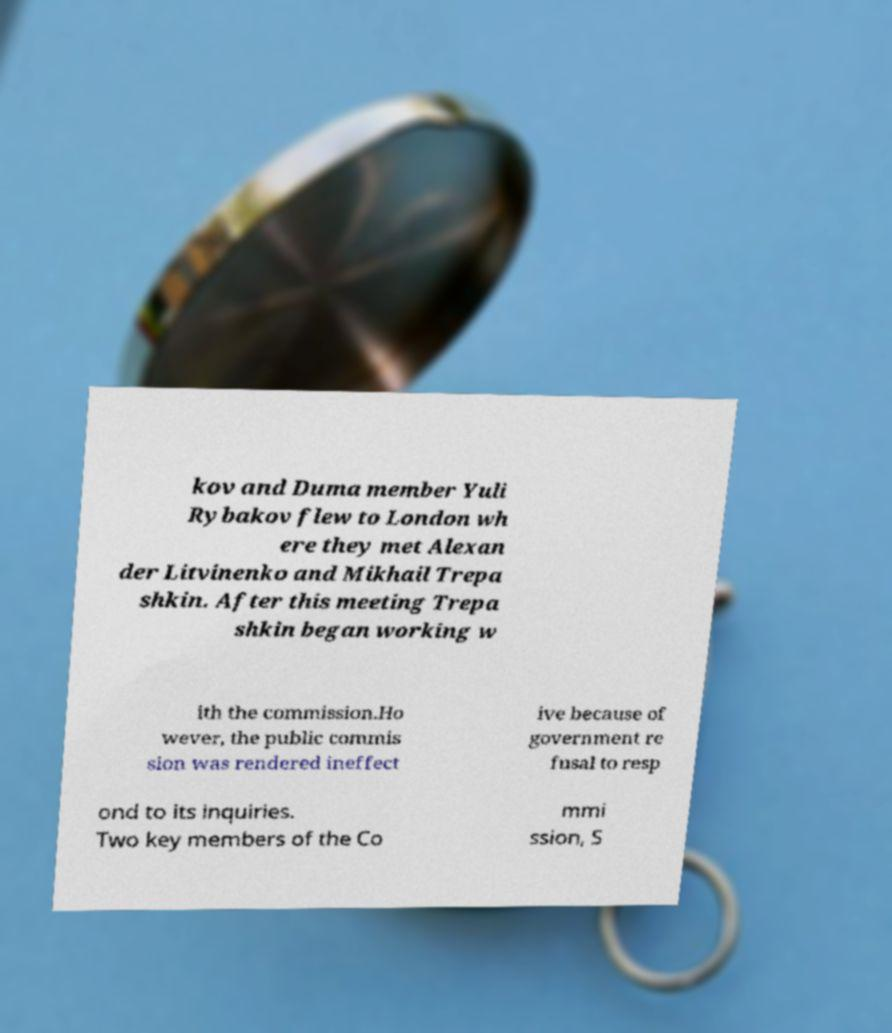There's text embedded in this image that I need extracted. Can you transcribe it verbatim? kov and Duma member Yuli Rybakov flew to London wh ere they met Alexan der Litvinenko and Mikhail Trepa shkin. After this meeting Trepa shkin began working w ith the commission.Ho wever, the public commis sion was rendered ineffect ive because of government re fusal to resp ond to its inquiries. Two key members of the Co mmi ssion, S 